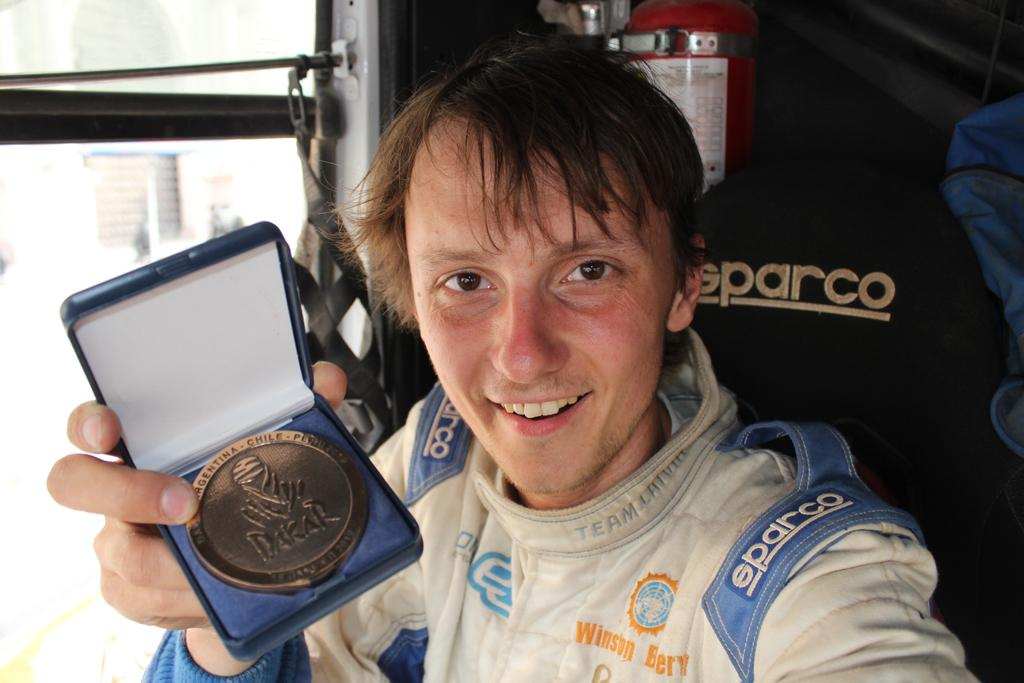What can be seen in the image? There is a person in the image. What is the person holding? The person is holding an object that appears to be a medal. What is visible in the background of the image? There is a window visible in the background of the image. How does the person interact with the crowd in the image? There is no crowd present in the image; it only features a person holding a medal and a window in the background. What type of brain can be seen in the image? There is no brain present in the image. 